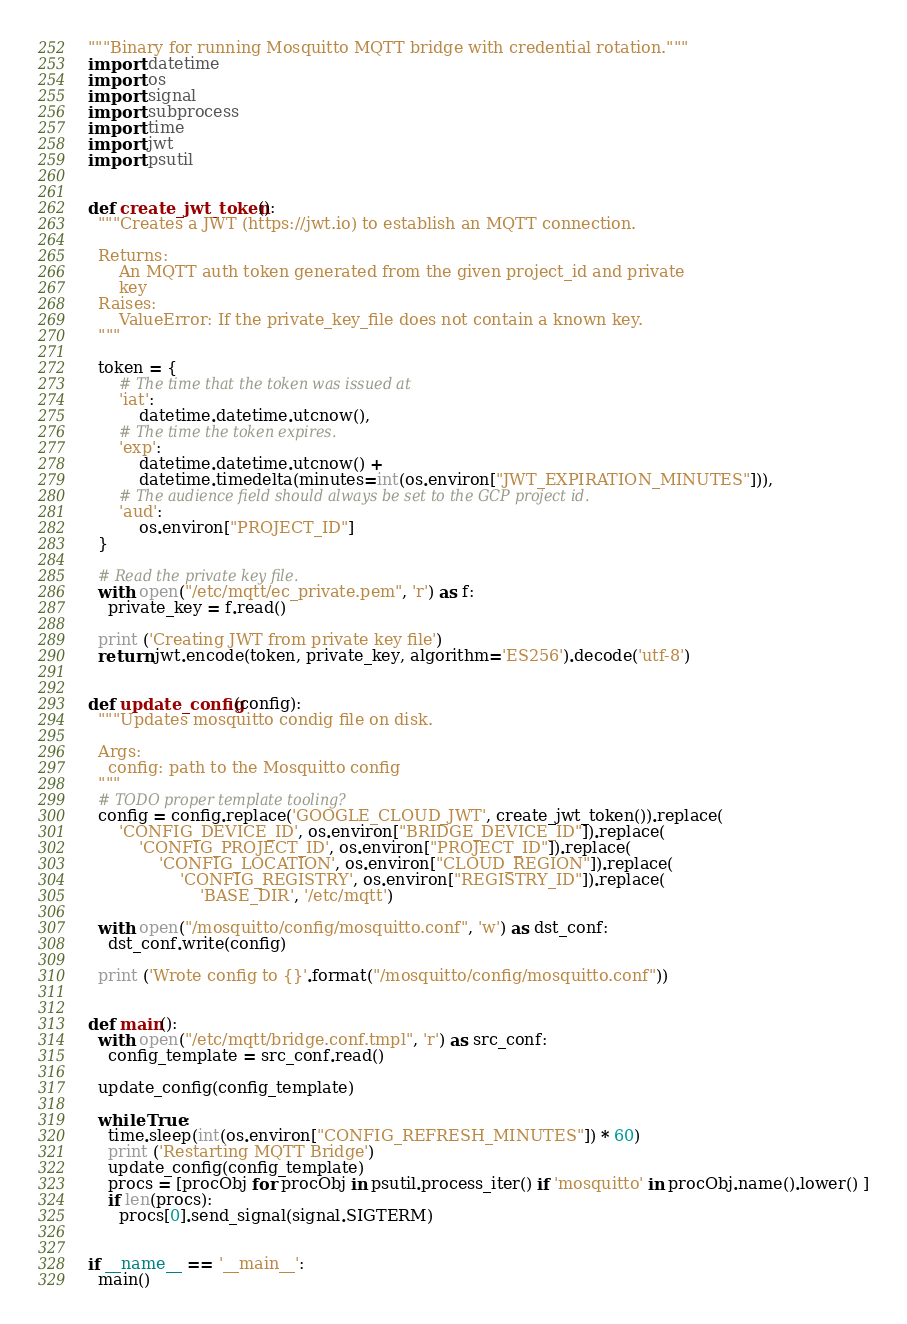Convert code to text. <code><loc_0><loc_0><loc_500><loc_500><_Python_>"""Binary for running Mosquitto MQTT bridge with credential rotation."""
import datetime
import os
import signal
import subprocess
import time
import jwt
import psutil


def create_jwt_token():
  """Creates a JWT (https://jwt.io) to establish an MQTT connection.

  Returns:
      An MQTT auth token generated from the given project_id and private
      key
  Raises:
      ValueError: If the private_key_file does not contain a known key.
  """

  token = {
      # The time that the token was issued at
      'iat':
          datetime.datetime.utcnow(),
      # The time the token expires.
      'exp':
          datetime.datetime.utcnow() +
          datetime.timedelta(minutes=int(os.environ["JWT_EXPIRATION_MINUTES"])),
      # The audience field should always be set to the GCP project id.
      'aud':
          os.environ["PROJECT_ID"]
  }

  # Read the private key file.
  with open("/etc/mqtt/ec_private.pem", 'r') as f:
    private_key = f.read()

  print ('Creating JWT from private key file')
  return jwt.encode(token, private_key, algorithm='ES256').decode('utf-8')


def update_config(config):
  """Updates mosquitto condig file on disk.

  Args:
    config: path to the Mosquitto config
  """
  # TODO proper template tooling?
  config = config.replace('GOOGLE_CLOUD_JWT', create_jwt_token()).replace(
      'CONFIG_DEVICE_ID', os.environ["BRIDGE_DEVICE_ID"]).replace(
          'CONFIG_PROJECT_ID', os.environ["PROJECT_ID"]).replace(
              'CONFIG_LOCATION', os.environ["CLOUD_REGION"]).replace(
                  'CONFIG_REGISTRY', os.environ["REGISTRY_ID"]).replace(
                      'BASE_DIR', '/etc/mqtt')

  with open("/mosquitto/config/mosquitto.conf", 'w') as dst_conf:
    dst_conf.write(config)

  print ('Wrote config to {}'.format("/mosquitto/config/mosquitto.conf"))


def main():
  with open("/etc/mqtt/bridge.conf.tmpl", 'r') as src_conf:
    config_template = src_conf.read()

  update_config(config_template)

  while True:
    time.sleep(int(os.environ["CONFIG_REFRESH_MINUTES"]) * 60)
    print ('Restarting MQTT Bridge')
    update_config(config_template)
    procs = [procObj for procObj in psutil.process_iter() if 'mosquitto' in procObj.name().lower() ]
    if len(procs):
      procs[0].send_signal(signal.SIGTERM)


if __name__ == '__main__':
  main()</code> 